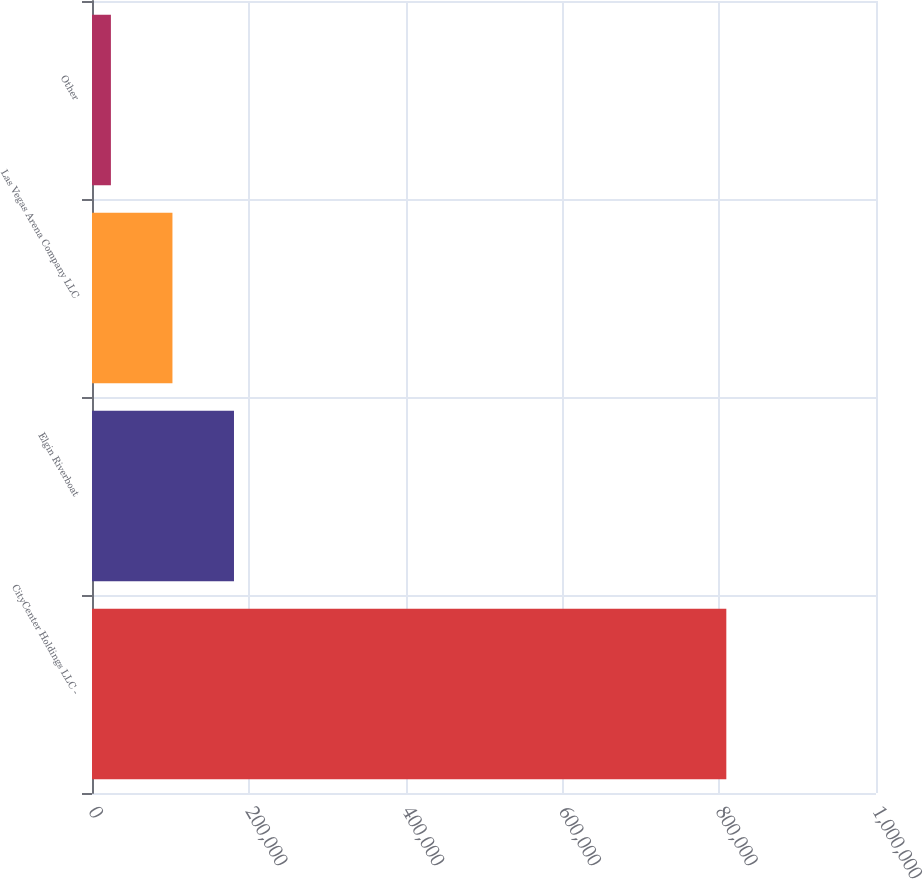Convert chart to OTSL. <chart><loc_0><loc_0><loc_500><loc_500><bar_chart><fcel>CityCenter Holdings LLC -<fcel>Elgin Riverboat<fcel>Las Vegas Arena Company LLC<fcel>Other<nl><fcel>809084<fcel>181110<fcel>102613<fcel>24116<nl></chart> 